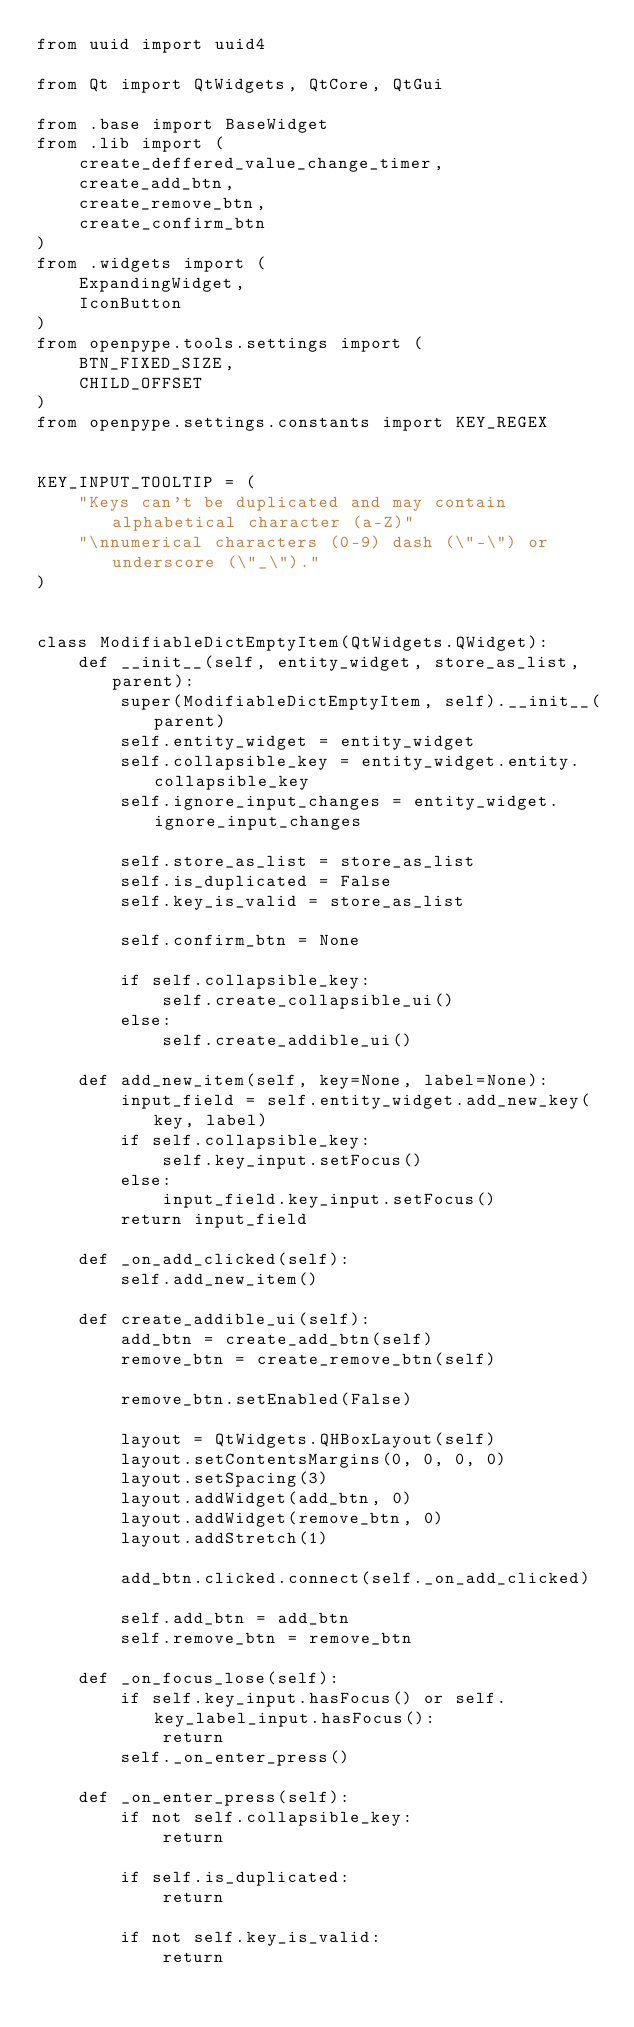<code> <loc_0><loc_0><loc_500><loc_500><_Python_>from uuid import uuid4

from Qt import QtWidgets, QtCore, QtGui

from .base import BaseWidget
from .lib import (
    create_deffered_value_change_timer,
    create_add_btn,
    create_remove_btn,
    create_confirm_btn
)
from .widgets import (
    ExpandingWidget,
    IconButton
)
from openpype.tools.settings import (
    BTN_FIXED_SIZE,
    CHILD_OFFSET
)
from openpype.settings.constants import KEY_REGEX


KEY_INPUT_TOOLTIP = (
    "Keys can't be duplicated and may contain alphabetical character (a-Z)"
    "\nnumerical characters (0-9) dash (\"-\") or underscore (\"_\")."
)


class ModifiableDictEmptyItem(QtWidgets.QWidget):
    def __init__(self, entity_widget, store_as_list, parent):
        super(ModifiableDictEmptyItem, self).__init__(parent)
        self.entity_widget = entity_widget
        self.collapsible_key = entity_widget.entity.collapsible_key
        self.ignore_input_changes = entity_widget.ignore_input_changes

        self.store_as_list = store_as_list
        self.is_duplicated = False
        self.key_is_valid = store_as_list

        self.confirm_btn = None

        if self.collapsible_key:
            self.create_collapsible_ui()
        else:
            self.create_addible_ui()

    def add_new_item(self, key=None, label=None):
        input_field = self.entity_widget.add_new_key(key, label)
        if self.collapsible_key:
            self.key_input.setFocus()
        else:
            input_field.key_input.setFocus()
        return input_field

    def _on_add_clicked(self):
        self.add_new_item()

    def create_addible_ui(self):
        add_btn = create_add_btn(self)
        remove_btn = create_remove_btn(self)

        remove_btn.setEnabled(False)

        layout = QtWidgets.QHBoxLayout(self)
        layout.setContentsMargins(0, 0, 0, 0)
        layout.setSpacing(3)
        layout.addWidget(add_btn, 0)
        layout.addWidget(remove_btn, 0)
        layout.addStretch(1)

        add_btn.clicked.connect(self._on_add_clicked)

        self.add_btn = add_btn
        self.remove_btn = remove_btn

    def _on_focus_lose(self):
        if self.key_input.hasFocus() or self.key_label_input.hasFocus():
            return
        self._on_enter_press()

    def _on_enter_press(self):
        if not self.collapsible_key:
            return

        if self.is_duplicated:
            return

        if not self.key_is_valid:
            return
</code> 